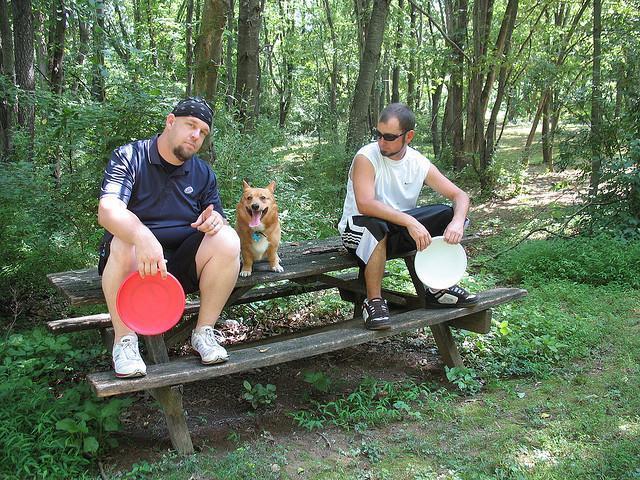How many dogs can you see?
Give a very brief answer. 1. How many people are there?
Give a very brief answer. 2. How many frisbees are visible?
Give a very brief answer. 2. 